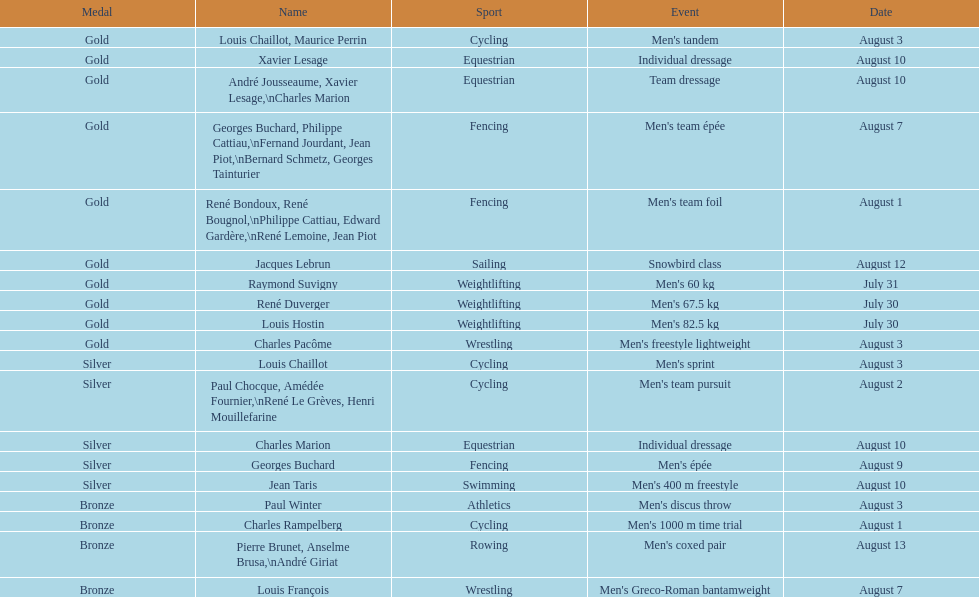In these olympics, what was this country's gold medal count? 10. 